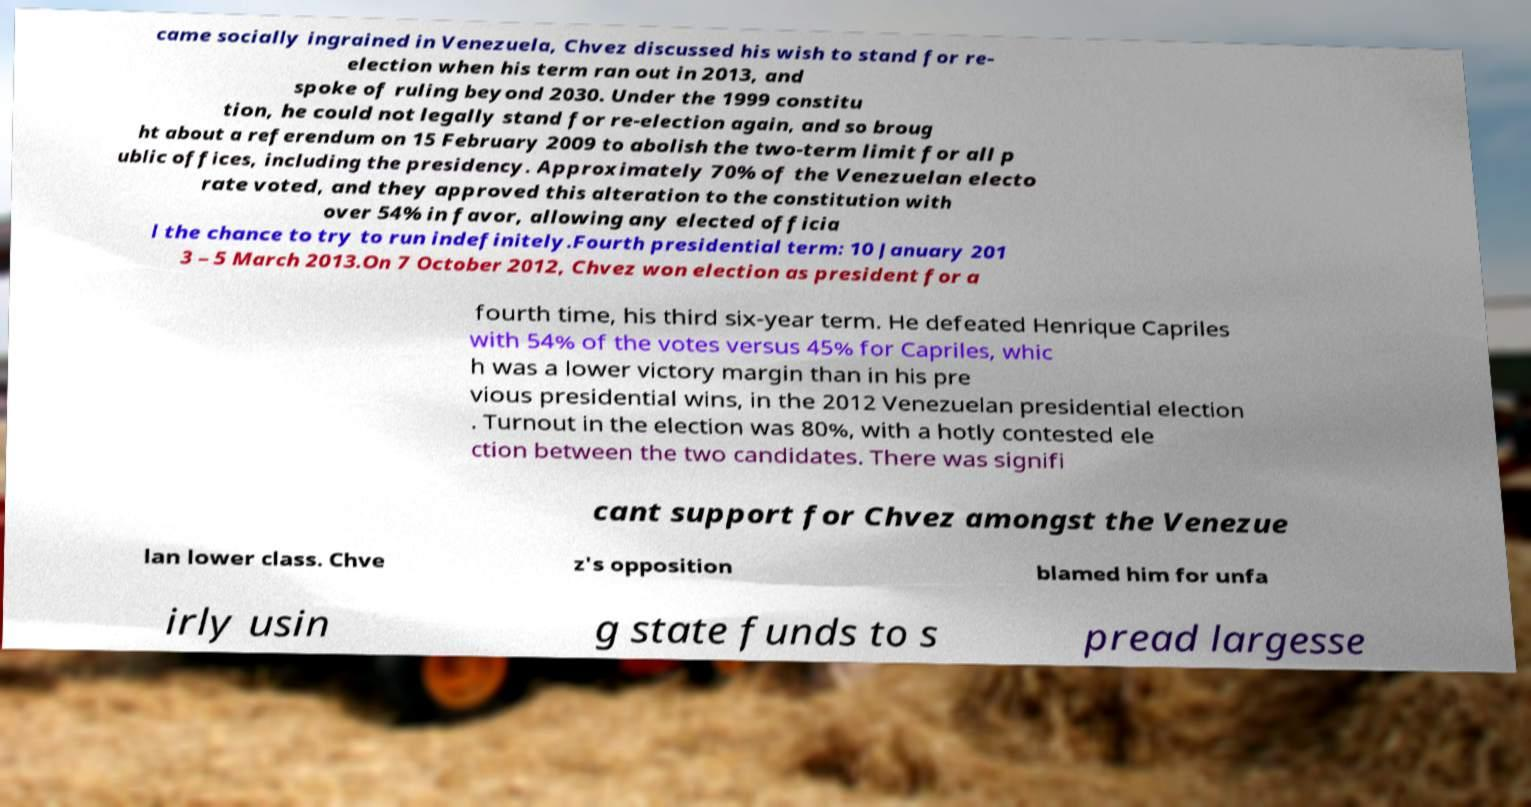Please read and relay the text visible in this image. What does it say? came socially ingrained in Venezuela, Chvez discussed his wish to stand for re- election when his term ran out in 2013, and spoke of ruling beyond 2030. Under the 1999 constitu tion, he could not legally stand for re-election again, and so broug ht about a referendum on 15 February 2009 to abolish the two-term limit for all p ublic offices, including the presidency. Approximately 70% of the Venezuelan electo rate voted, and they approved this alteration to the constitution with over 54% in favor, allowing any elected officia l the chance to try to run indefinitely.Fourth presidential term: 10 January 201 3 – 5 March 2013.On 7 October 2012, Chvez won election as president for a fourth time, his third six-year term. He defeated Henrique Capriles with 54% of the votes versus 45% for Capriles, whic h was a lower victory margin than in his pre vious presidential wins, in the 2012 Venezuelan presidential election . Turnout in the election was 80%, with a hotly contested ele ction between the two candidates. There was signifi cant support for Chvez amongst the Venezue lan lower class. Chve z's opposition blamed him for unfa irly usin g state funds to s pread largesse 